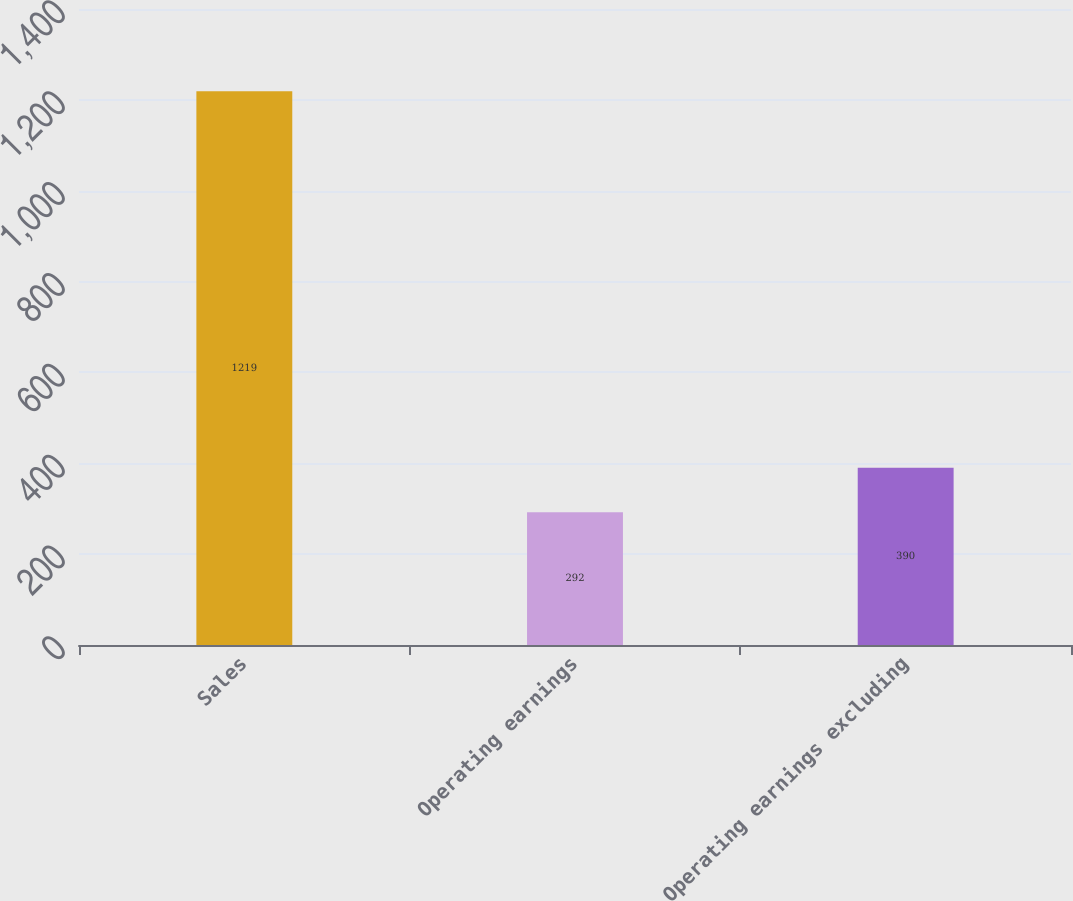Convert chart to OTSL. <chart><loc_0><loc_0><loc_500><loc_500><bar_chart><fcel>Sales<fcel>Operating earnings<fcel>Operating earnings excluding<nl><fcel>1219<fcel>292<fcel>390<nl></chart> 